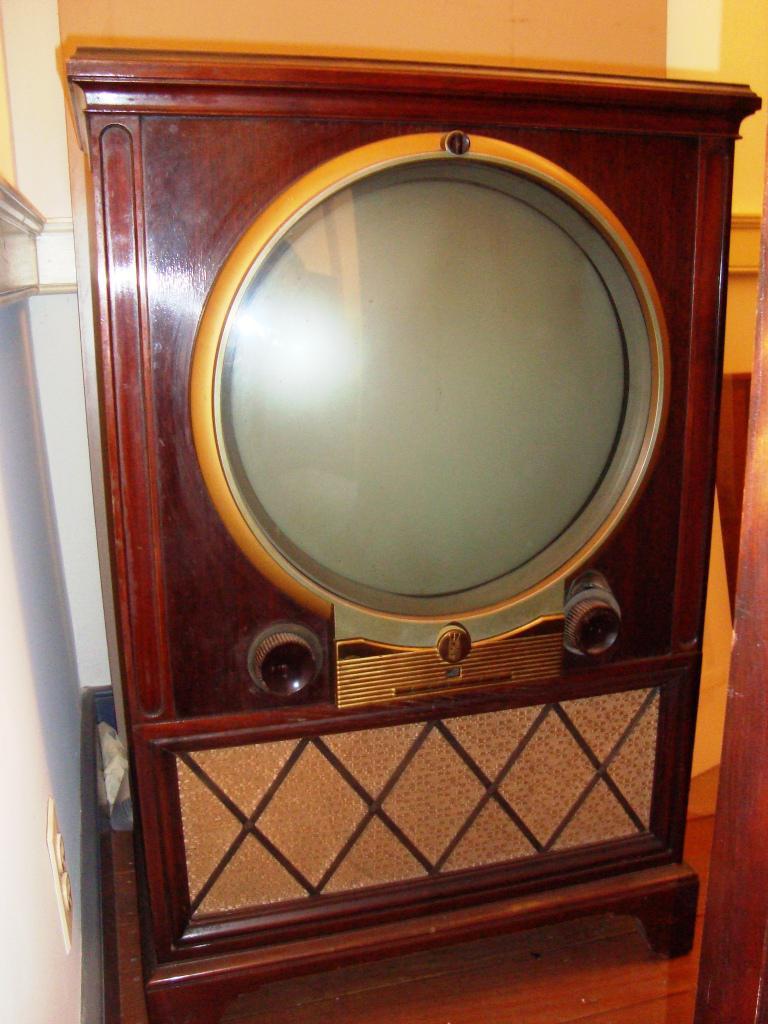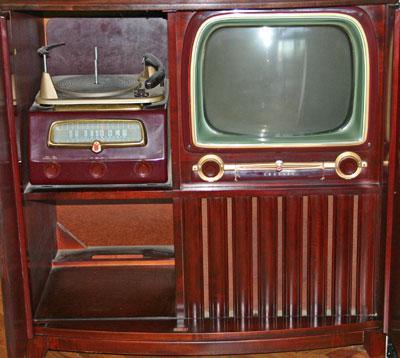The first image is the image on the left, the second image is the image on the right. Assess this claim about the two images: "The speaker under one of the television monitors shows a horizontal brick-like pattern.". Correct or not? Answer yes or no. No. The first image is the image on the left, the second image is the image on the right. Considering the images on both sides, is "In at lease on image, there is a oval shaped tv screen held by wooden tv case that has three rows of brick like rectangles." valid? Answer yes or no. No. 